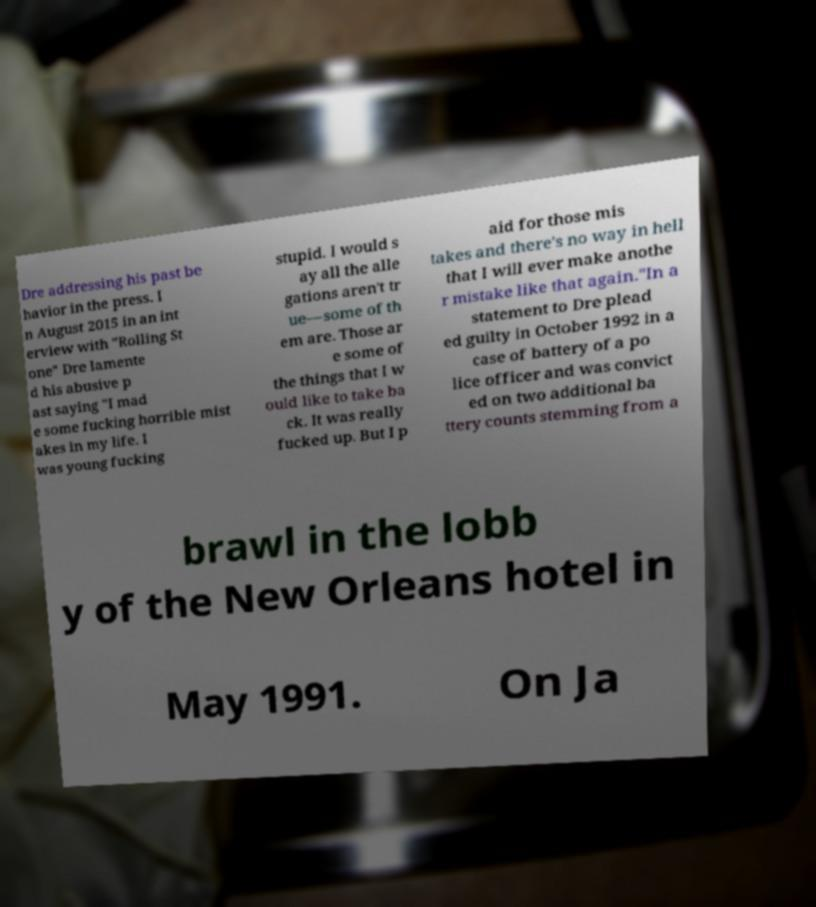Could you assist in decoding the text presented in this image and type it out clearly? Dre addressing his past be havior in the press. I n August 2015 in an int erview with "Rolling St one" Dre lamente d his abusive p ast saying "I mad e some fucking horrible mist akes in my life. I was young fucking stupid. I would s ay all the alle gations aren't tr ue—some of th em are. Those ar e some of the things that I w ould like to take ba ck. It was really fucked up. But I p aid for those mis takes and there's no way in hell that I will ever make anothe r mistake like that again."In a statement to Dre plead ed guilty in October 1992 in a case of battery of a po lice officer and was convict ed on two additional ba ttery counts stemming from a brawl in the lobb y of the New Orleans hotel in May 1991. On Ja 